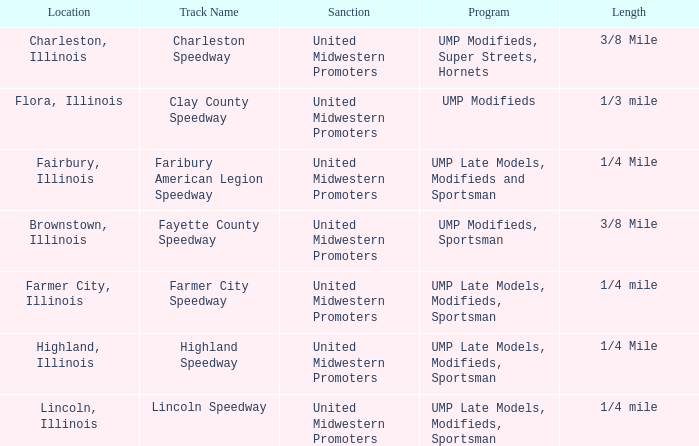What location is farmer city speedway? Farmer City, Illinois. 